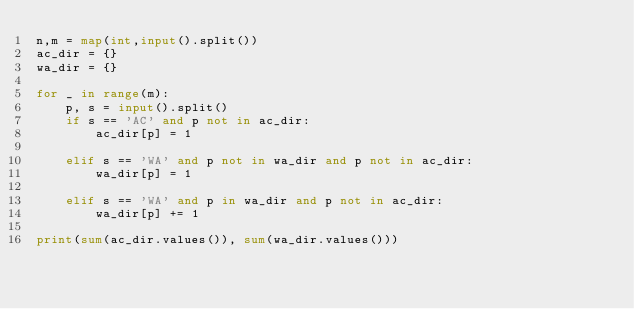Convert code to text. <code><loc_0><loc_0><loc_500><loc_500><_Python_>n,m = map(int,input().split())
ac_dir = {}
wa_dir = {}

for _ in range(m):
    p, s = input().split()
    if s == 'AC' and p not in ac_dir:
        ac_dir[p] = 1
    
    elif s == 'WA' and p not in wa_dir and p not in ac_dir:
        wa_dir[p] = 1
    
    elif s == 'WA' and p in wa_dir and p not in ac_dir:
        wa_dir[p] += 1

print(sum(ac_dir.values()), sum(wa_dir.values()))</code> 